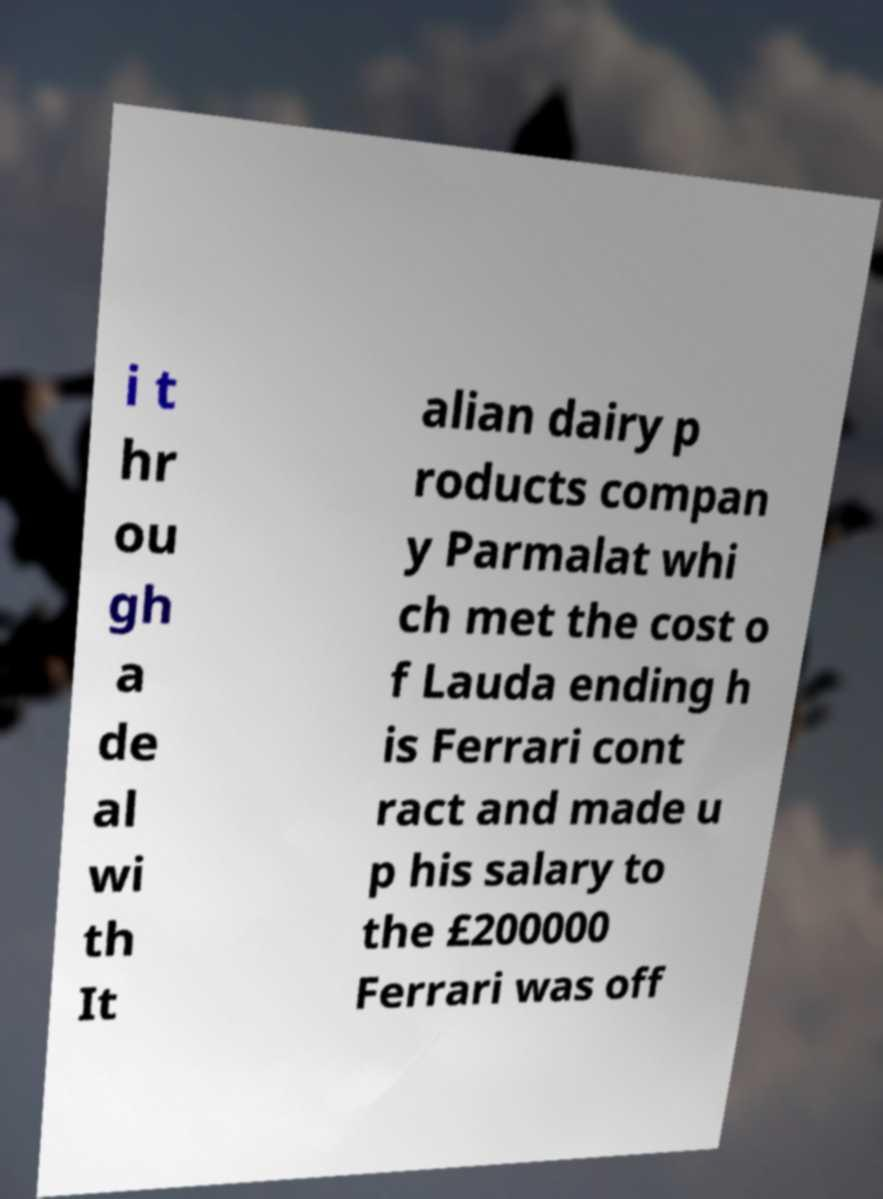Please identify and transcribe the text found in this image. i t hr ou gh a de al wi th It alian dairy p roducts compan y Parmalat whi ch met the cost o f Lauda ending h is Ferrari cont ract and made u p his salary to the £200000 Ferrari was off 